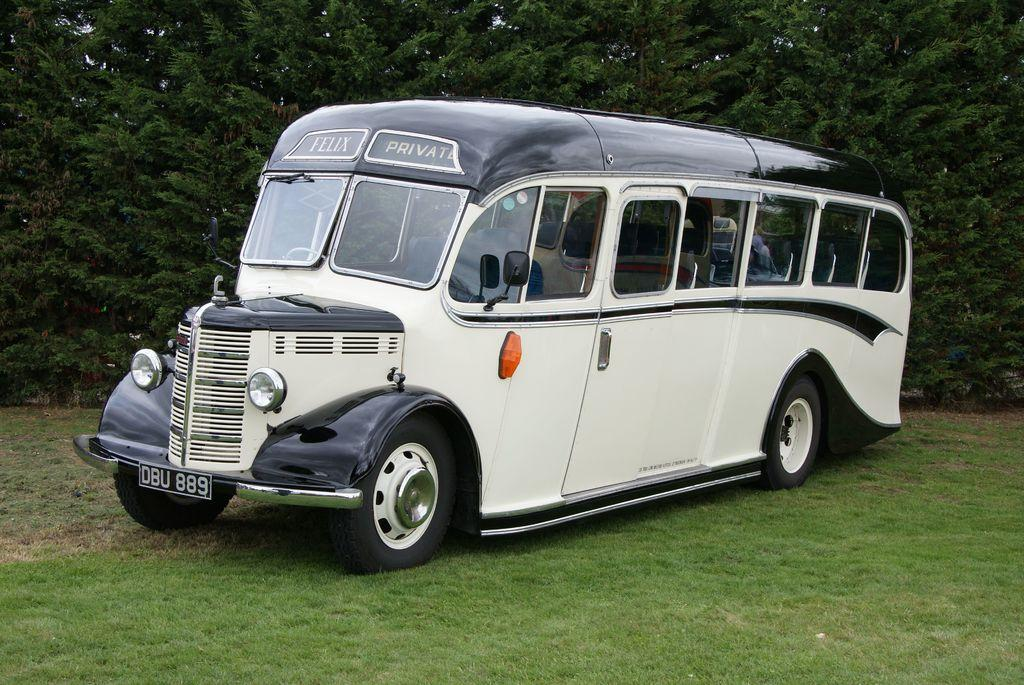Provide a one-sentence caption for the provided image. Oddly shaped bus that is apparently for private use only. 